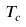Convert formula to latex. <formula><loc_0><loc_0><loc_500><loc_500>\, T _ { c }</formula> 